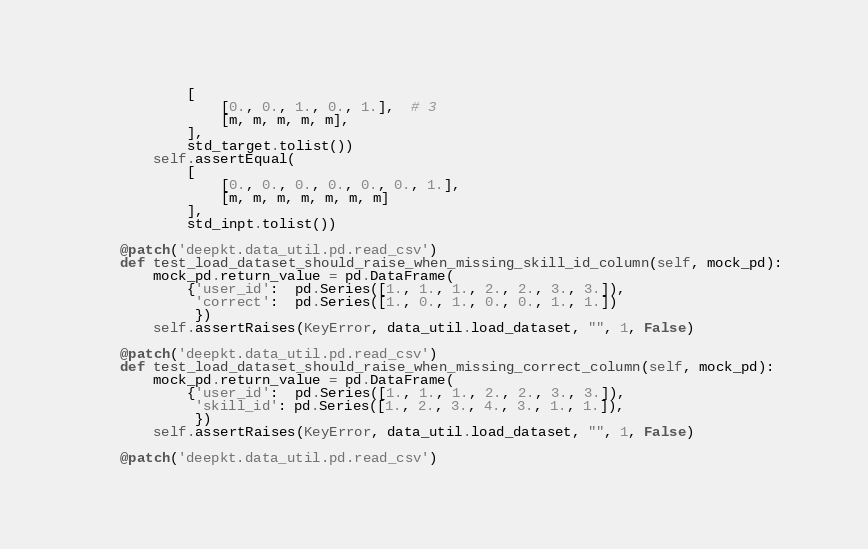<code> <loc_0><loc_0><loc_500><loc_500><_Python_>            [
                [0., 0., 1., 0., 1.],  # 3
                [m, m, m, m, m],
            ],
            std_target.tolist())
        self.assertEqual(
            [
                [0., 0., 0., 0., 0., 0., 1.],
                [m, m, m, m, m, m, m]
            ],
            std_inpt.tolist())

    @patch('deepkt.data_util.pd.read_csv')
    def test_load_dataset_should_raise_when_missing_skill_id_column(self, mock_pd):
        mock_pd.return_value = pd.DataFrame(
            {'user_id':  pd.Series([1., 1., 1., 2., 2., 3., 3.]),
             'correct':  pd.Series([1., 0., 1., 0., 0., 1., 1.])
             })
        self.assertRaises(KeyError, data_util.load_dataset, "", 1, False)

    @patch('deepkt.data_util.pd.read_csv')
    def test_load_dataset_should_raise_when_missing_correct_column(self, mock_pd):
        mock_pd.return_value = pd.DataFrame(
            {'user_id':  pd.Series([1., 1., 1., 2., 2., 3., 3.]),
             'skill_id': pd.Series([1., 2., 3., 4., 3., 1., 1.]),
             })
        self.assertRaises(KeyError, data_util.load_dataset, "", 1, False)

    @patch('deepkt.data_util.pd.read_csv')</code> 